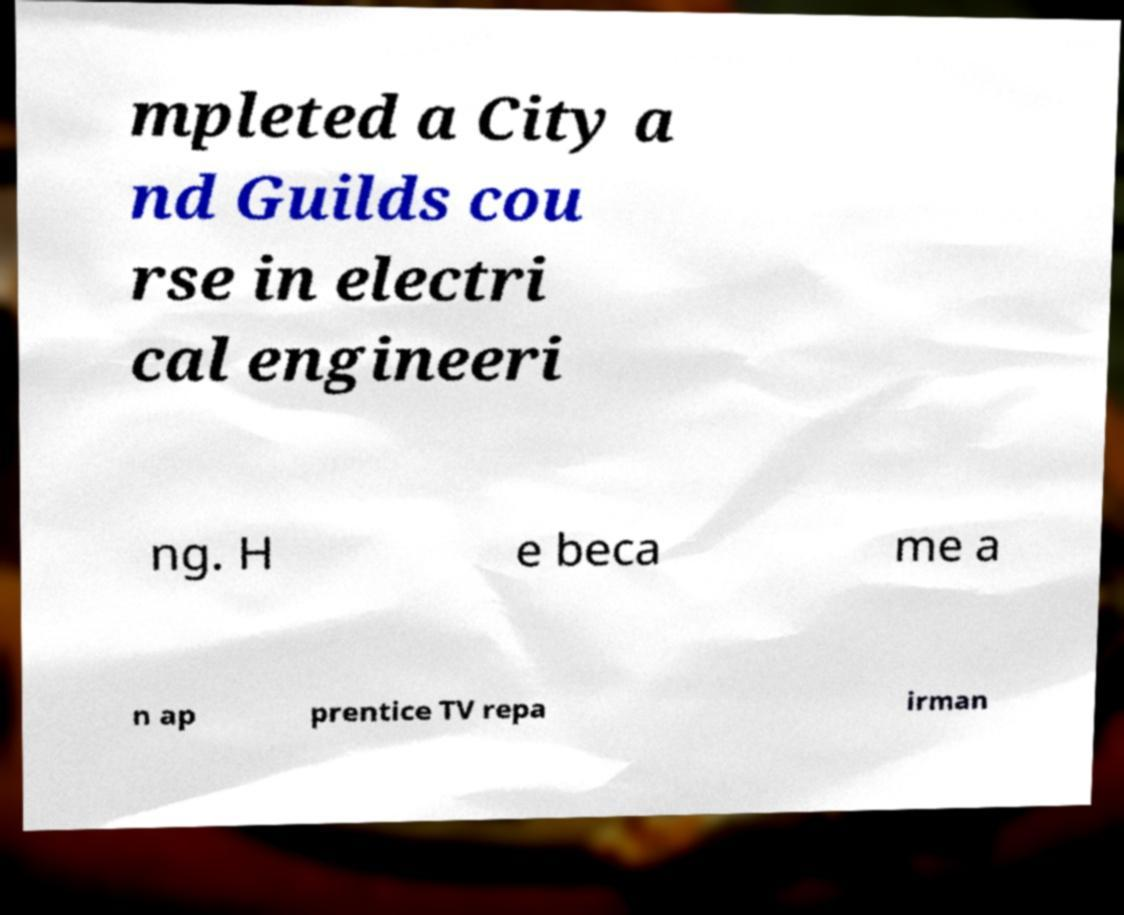Could you extract and type out the text from this image? mpleted a City a nd Guilds cou rse in electri cal engineeri ng. H e beca me a n ap prentice TV repa irman 